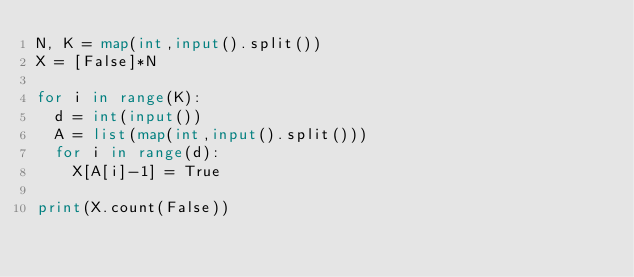Convert code to text. <code><loc_0><loc_0><loc_500><loc_500><_Python_>N, K = map(int,input().split())
X = [False]*N

for i in range(K):
	d = int(input())
	A = list(map(int,input().split()))
	for i in range(d):
		X[A[i]-1] = True
		
print(X.count(False))</code> 